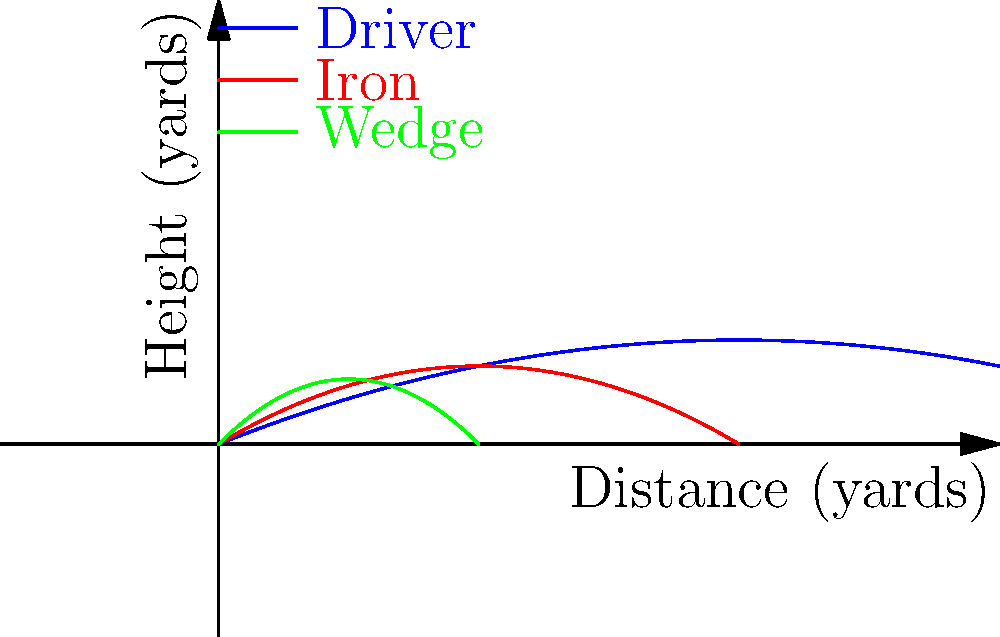Analyzing the trajectory paths of golf balls hit with different clubs, which club would be most suitable for achieving maximum height while sacrificing some distance, similar to a shot the Coody family might use to clear a tall obstacle on the course? To answer this question, we need to analyze the trajectory paths shown in the diagram for each club:

1. Driver (blue line):
   - Provides the longest distance
   - Relatively low initial trajectory
   - Reaches a moderate maximum height

2. Iron (red line):
   - Offers a medium distance
   - Has a steeper initial trajectory than the driver
   - Achieves a higher maximum height compared to the driver

3. Wedge (green line):
   - Covers the shortest distance
   - Has the steepest initial trajectory
   - Reaches the highest maximum height relative to its distance

The question asks for the club that achieves maximum height while sacrificing some distance, similar to clearing a tall obstacle. This description best fits the wedge:

- It has the steepest initial trajectory, allowing it to quickly gain height.
- It reaches the highest point relative to its total distance traveled.
- It sacrifices distance compared to the other clubs, which is acceptable for the given scenario.

The Coody family, known for their strategic play, would likely choose a wedge for such a shot to clear a tall obstacle while maintaining control over the ball's flight and landing.
Answer: Wedge 